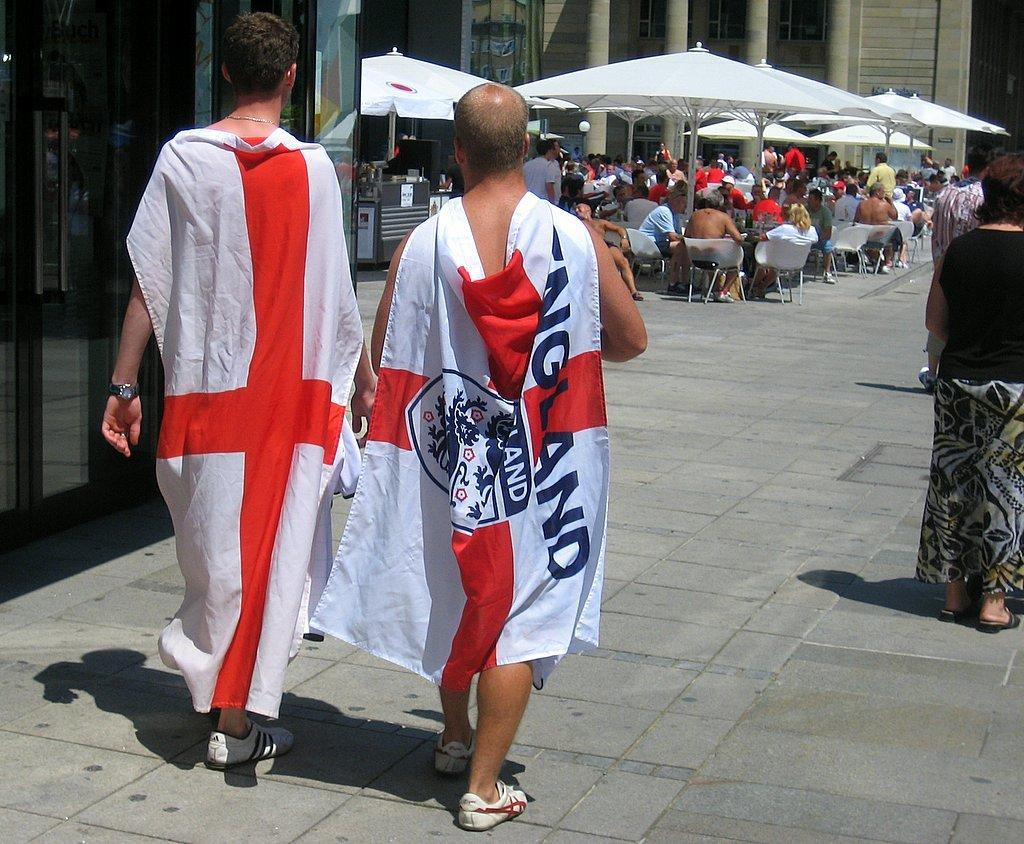<image>
Create a compact narrative representing the image presented. Two mane walking toward some table wearing only a England flag 